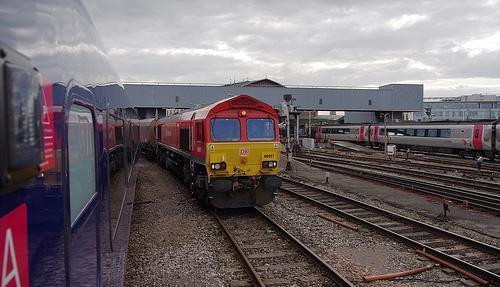How many trains can be seen?
Give a very brief answer. 3. 